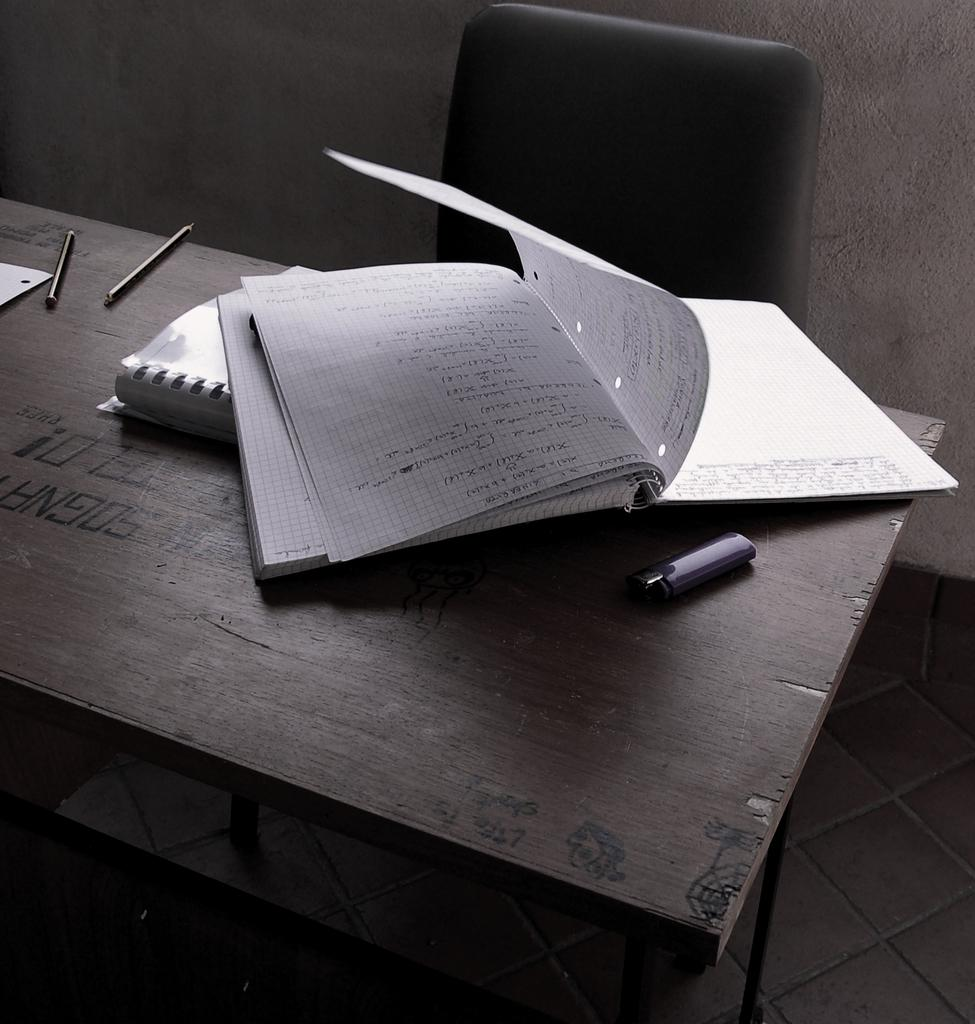<image>
Provide a brief description of the given image. Open booklet or journal on top of a wooden table with a letter G on it. 